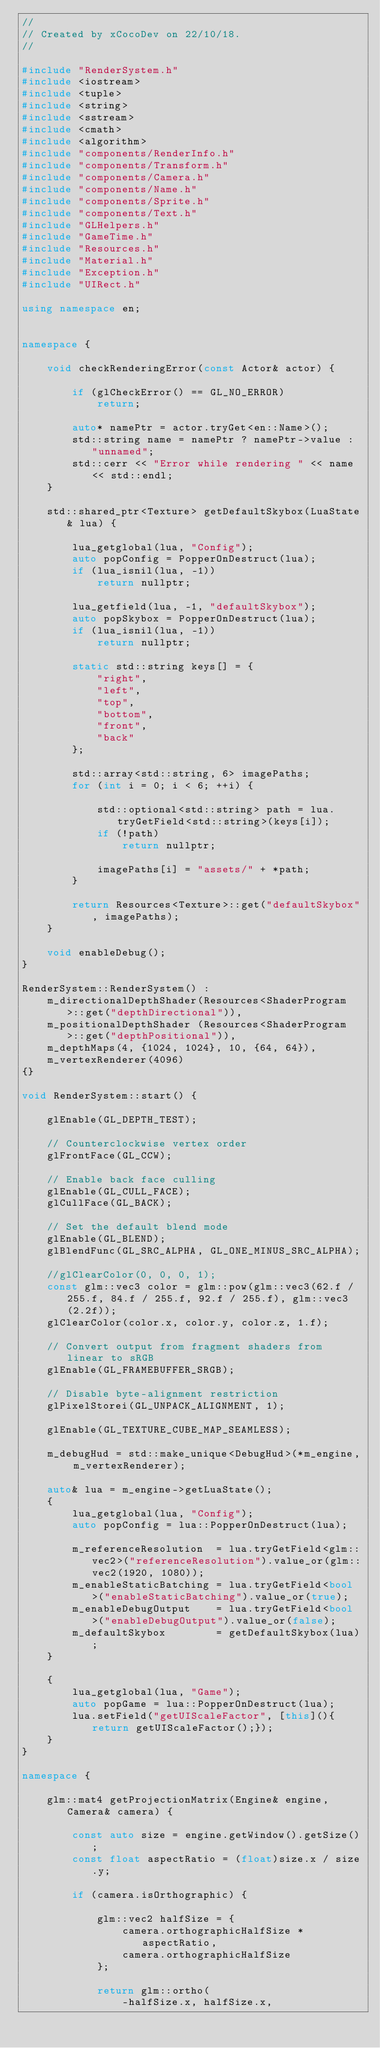<code> <loc_0><loc_0><loc_500><loc_500><_C++_>//
// Created by xCocoDev on 22/10/18.
//

#include "RenderSystem.h"
#include <iostream>
#include <tuple>
#include <string>
#include <sstream>
#include <cmath>
#include <algorithm>
#include "components/RenderInfo.h"
#include "components/Transform.h"
#include "components/Camera.h"
#include "components/Name.h"
#include "components/Sprite.h"
#include "components/Text.h"
#include "GLHelpers.h"
#include "GameTime.h"
#include "Resources.h"
#include "Material.h"
#include "Exception.h"
#include "UIRect.h"

using namespace en;


namespace {

    void checkRenderingError(const Actor& actor) {

        if (glCheckError() == GL_NO_ERROR)
            return;

        auto* namePtr = actor.tryGet<en::Name>();
        std::string name = namePtr ? namePtr->value : "unnamed";
        std::cerr << "Error while rendering " << name << std::endl;
    }

    std::shared_ptr<Texture> getDefaultSkybox(LuaState& lua) {

        lua_getglobal(lua, "Config");
        auto popConfig = PopperOnDestruct(lua);
        if (lua_isnil(lua, -1))
            return nullptr;

        lua_getfield(lua, -1, "defaultSkybox");
        auto popSkybox = PopperOnDestruct(lua);
        if (lua_isnil(lua, -1))
            return nullptr;

        static std::string keys[] = {
            "right",
            "left",
            "top",
            "bottom",
            "front",
            "back"
        };

        std::array<std::string, 6> imagePaths;
        for (int i = 0; i < 6; ++i) {

            std::optional<std::string> path = lua.tryGetField<std::string>(keys[i]);
            if (!path)
                return nullptr;

            imagePaths[i] = "assets/" + *path;
        }

        return Resources<Texture>::get("defaultSkybox", imagePaths);
    }

    void enableDebug();
}

RenderSystem::RenderSystem() :
    m_directionalDepthShader(Resources<ShaderProgram>::get("depthDirectional")),
    m_positionalDepthShader (Resources<ShaderProgram>::get("depthPositional")),
    m_depthMaps(4, {1024, 1024}, 10, {64, 64}),
    m_vertexRenderer(4096)
{}

void RenderSystem::start() {

    glEnable(GL_DEPTH_TEST);

    // Counterclockwise vertex order
    glFrontFace(GL_CCW);

    // Enable back face culling
    glEnable(GL_CULL_FACE);
    glCullFace(GL_BACK);

    // Set the default blend mode
    glEnable(GL_BLEND);
    glBlendFunc(GL_SRC_ALPHA, GL_ONE_MINUS_SRC_ALPHA);

    //glClearColor(0, 0, 0, 1);
    const glm::vec3 color = glm::pow(glm::vec3(62.f / 255.f, 84.f / 255.f, 92.f / 255.f), glm::vec3(2.2f));
    glClearColor(color.x, color.y, color.z, 1.f);

    // Convert output from fragment shaders from linear to sRGB
    glEnable(GL_FRAMEBUFFER_SRGB);

    // Disable byte-alignment restriction
    glPixelStorei(GL_UNPACK_ALIGNMENT, 1);

    glEnable(GL_TEXTURE_CUBE_MAP_SEAMLESS);

    m_debugHud = std::make_unique<DebugHud>(*m_engine, m_vertexRenderer);

    auto& lua = m_engine->getLuaState();
    {
        lua_getglobal(lua, "Config");
        auto popConfig = lua::PopperOnDestruct(lua);

        m_referenceResolution  = lua.tryGetField<glm::vec2>("referenceResolution").value_or(glm::vec2(1920, 1080));
        m_enableStaticBatching = lua.tryGetField<bool>("enableStaticBatching").value_or(true);
        m_enableDebugOutput    = lua.tryGetField<bool>("enableDebugOutput").value_or(false);
        m_defaultSkybox        = getDefaultSkybox(lua);
    }

    {
        lua_getglobal(lua, "Game");
        auto popGame = lua::PopperOnDestruct(lua);
        lua.setField("getUIScaleFactor", [this](){return getUIScaleFactor();});
    }
}

namespace {

    glm::mat4 getProjectionMatrix(Engine& engine, Camera& camera) {

        const auto size = engine.getWindow().getSize();
        const float aspectRatio = (float)size.x / size.y;

        if (camera.isOrthographic) {

            glm::vec2 halfSize = {
                camera.orthographicHalfSize * aspectRatio,
                camera.orthographicHalfSize
            };

            return glm::ortho(
                -halfSize.x, halfSize.x,</code> 